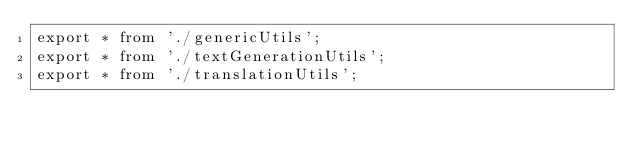<code> <loc_0><loc_0><loc_500><loc_500><_JavaScript_>export * from './genericUtils';
export * from './textGenerationUtils';
export * from './translationUtils';</code> 